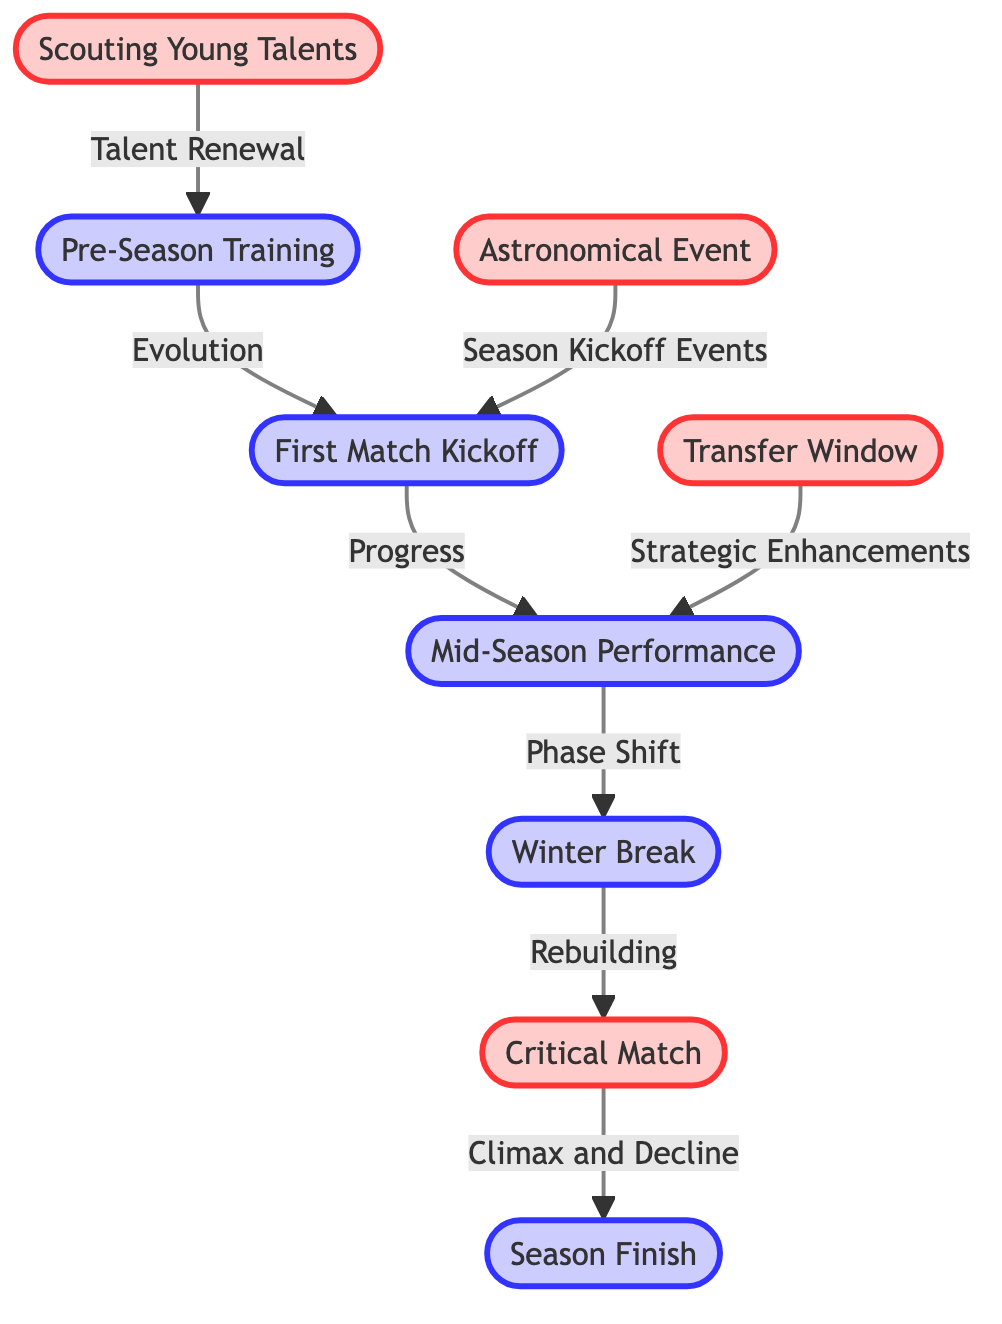What is the first event of the season according to the diagram? The diagram shows that the first event is labeled as "First Match Kickoff." This is the first node connected to the "Pre-Season Training."
Answer: First Match Kickoff How many nodes are present in the diagram? By counting the nodes visually represented in the diagram, there are eight distinct nodes: Pre-Season Training, First Match Kickoff, Mid-Season Performance, Winter Break, Critical Match, Season Finish, Scouting Young Talents, and Transfer Window.
Answer: 8 What is the last phase of the football season indicated in the diagram? The last phase represented in the diagram is "Season Finish," which follows the "Critical Match." This indicates the conclusion of the season's timeline.
Answer: Season Finish What connects the "Mid-Season Performance" to the "Winter Break"? The diagram specifies that there is a relationship labeled "Phase Shift" between "Mid-Season Performance" and "Winter Break." This indicates a transitional phase in the timeline.
Answer: Phase Shift What type of event is labeled as occurring during the winter break? The diagram does not directly list events for the winter break but shows a node labeled “Winter Break,” indicating a period within the season without specific events detailed.
Answer: No specific event Which node reflects the process of talent acquisition? The node labeled "Scouting Young Talents" represents the process of talent acquisition and renewal within the context of the football season timeline.
Answer: Scouting Young Talents What does the connection from "Transfer Window" indicate regarding mid-season? The connection is labeled as "Strategic Enhancements," implying that the transfer window is a critical time for making enhancements to the team during the mid-season.
Answer: Strategic Enhancements What marks the climax of the football season in this diagram? The diagram indicates the "Critical Match" as the climax of the season, connected directly to the preceding phase of "Winter Break."
Answer: Critical Match How does the "Pre-Season Training" influence the "First Match Kickoff"? The diagram shows a direct connection from "Pre-Season Training" to "First Match Kickoff," labeled as "Evolution," indicating that the outcomes of training lead directly to the season's start.
Answer: Evolution 